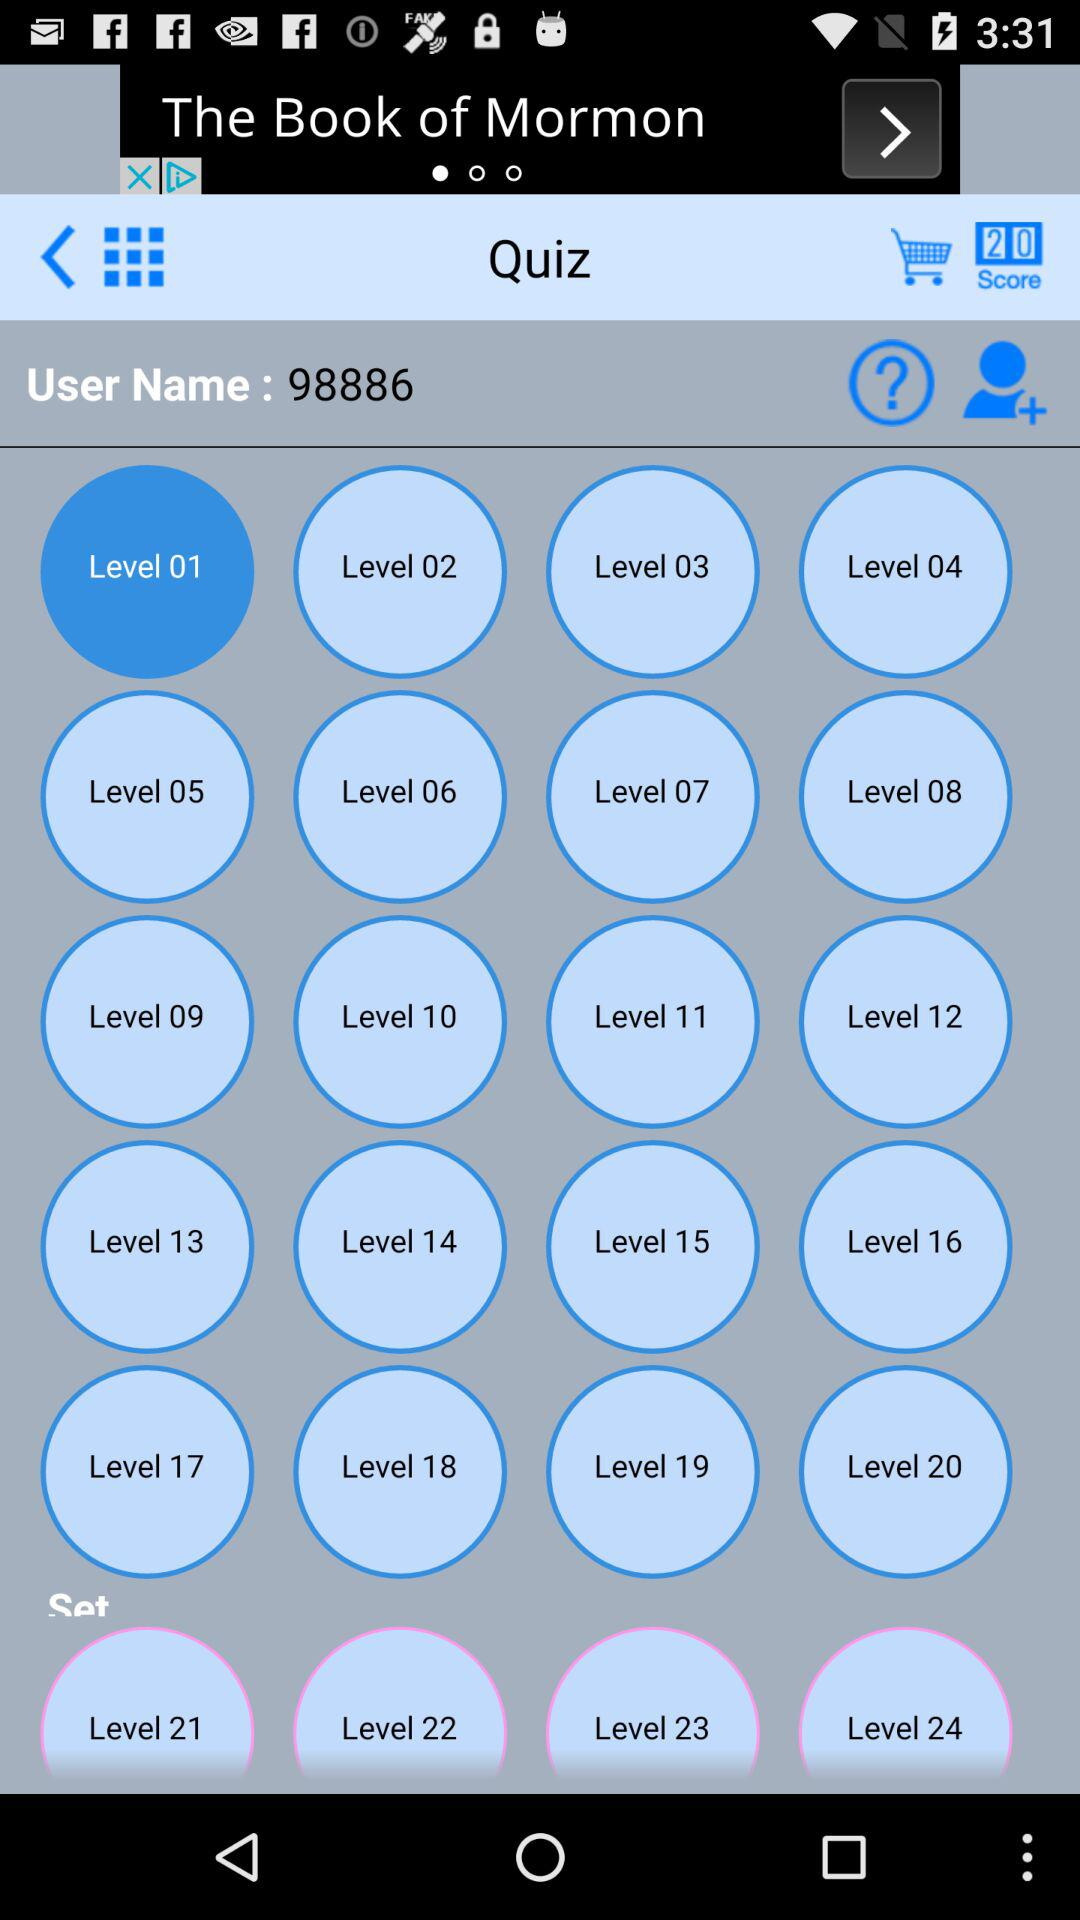What is the user name? The user name is 98886. 